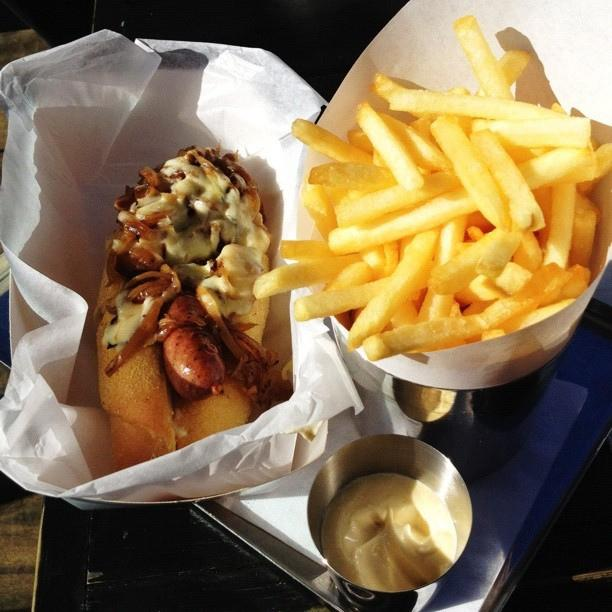What place sells these items?

Choices:
A) taco bell
B) home depot
C) sonic
D) staples sonic 